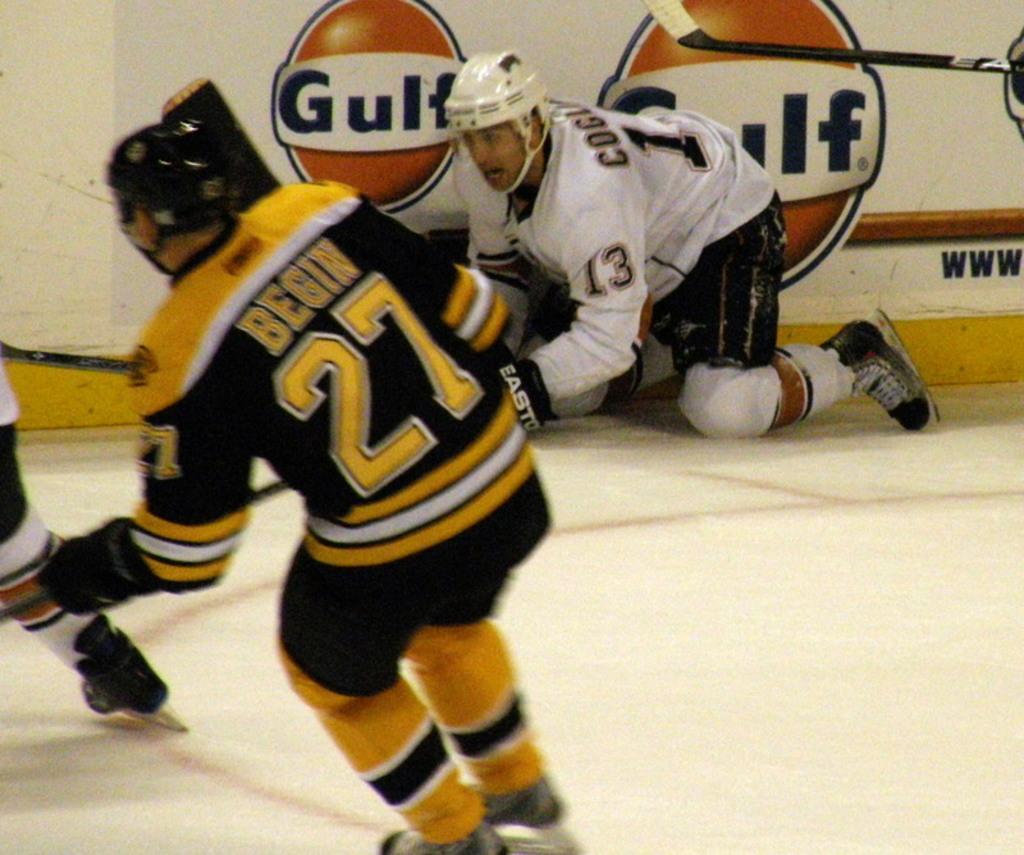How would you summarize this image in a sentence or two? In the image there are few men sliding on the ice floor, they are playing ice hockey and in the back there is wall. 